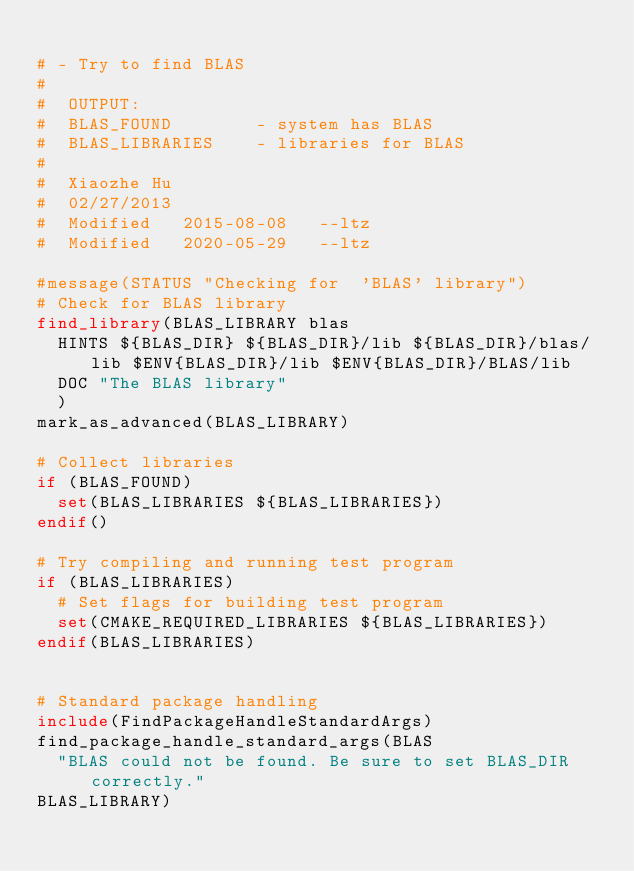<code> <loc_0><loc_0><loc_500><loc_500><_CMake_>
# - Try to find BLAS
#  
#  OUTPUT:
#  BLAS_FOUND        - system has BLAS
#  BLAS_LIBRARIES    - libraries for BLAS
#
#  Xiaozhe Hu
#  02/27/2013
#  Modified   2015-08-08   --ltz
#  Modified   2020-05-29   --ltz

#message(STATUS "Checking for  'BLAS' library")
# Check for BLAS library
find_library(BLAS_LIBRARY blas
  HINTS ${BLAS_DIR} ${BLAS_DIR}/lib ${BLAS_DIR}/blas/lib $ENV{BLAS_DIR}/lib $ENV{BLAS_DIR}/BLAS/lib
  DOC "The BLAS library"
  )
mark_as_advanced(BLAS_LIBRARY)

# Collect libraries
if (BLAS_FOUND)
  set(BLAS_LIBRARIES ${BLAS_LIBRARIES})
endif()

# Try compiling and running test program
if (BLAS_LIBRARIES)
  # Set flags for building test program
  set(CMAKE_REQUIRED_LIBRARIES ${BLAS_LIBRARIES})
endif(BLAS_LIBRARIES)


# Standard package handling
include(FindPackageHandleStandardArgs)
find_package_handle_standard_args(BLAS
  "BLAS could not be found. Be sure to set BLAS_DIR correctly."
BLAS_LIBRARY)
</code> 